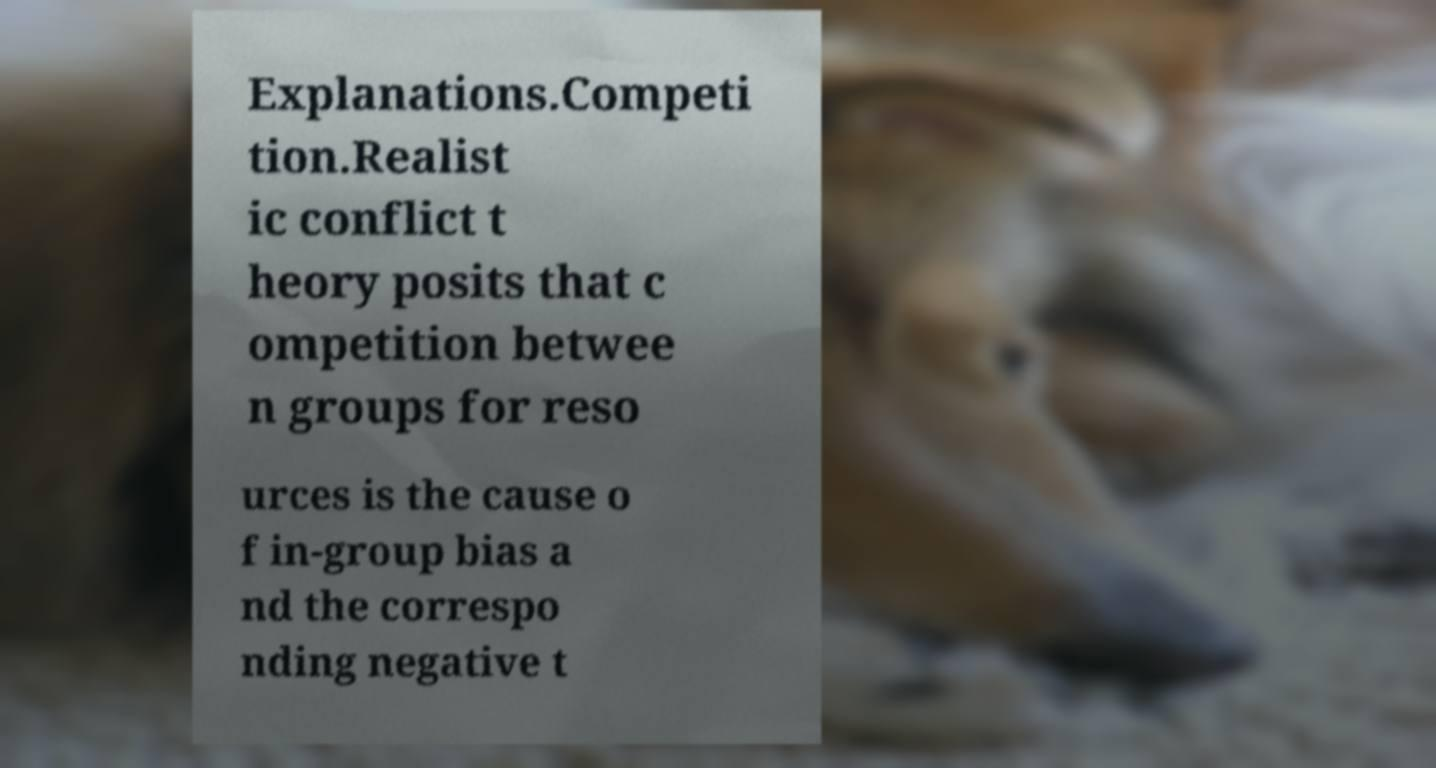Could you extract and type out the text from this image? Explanations.Competi tion.Realist ic conflict t heory posits that c ompetition betwee n groups for reso urces is the cause o f in-group bias a nd the correspo nding negative t 